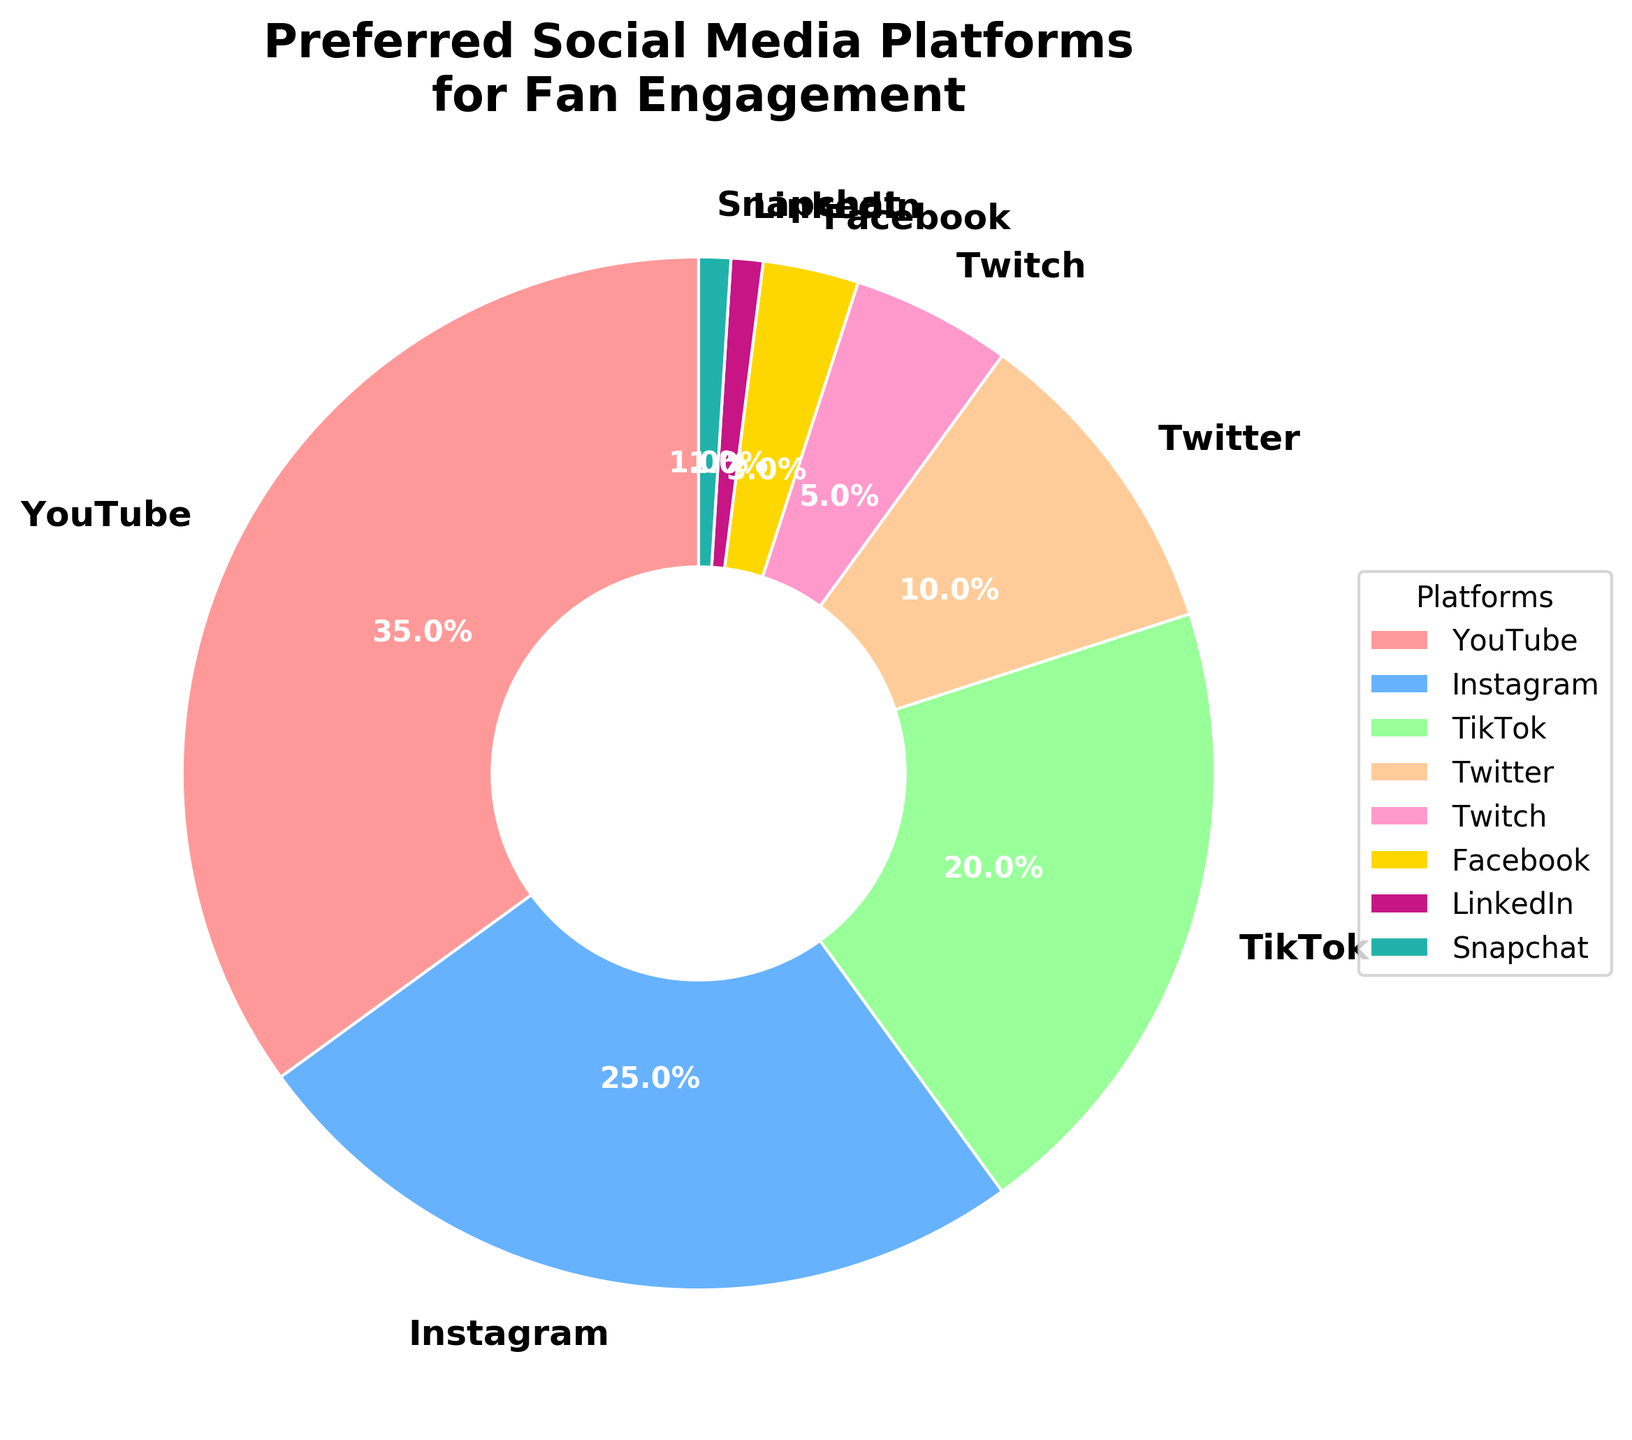what percentage of celebrities prefer YouTube for fan engagement? The figure shows a pie chart with different social media platforms and their corresponding percentages. To find the percentage of celebrities who prefer YouTube, simply refer to the slice labeled "YouTube".
Answer: 35% How does the preference for Instagram compare to Twitter? Look at the slices labeled "Instagram" and "Twitter" in the pie chart. Instagram has a larger slice. From the labels, Instagram is 25% and Twitter is 10%. Since 25% is greater than 10%, celebrities prefer Instagram more than Twitter.
Answer: Instagram (25%) is preferred more than Twitter (10%) If we combine the preferences for TikTok and Twitch, what percentage do we get? Find the percentages for TikTok and Twitch from the pie chart. TikTok is 20% and Twitch is 5%. Add these two percentages together: 20% + 5% = 25%.
Answer: 25% Which platform is the least preferred among the celebrities for fan engagement? Check the smallest slice in the pie chart. The platforms with the smallest slices are LinkedIn and Snapchat, both at 1%. Since they have the same percentage, they are equally the least preferred.
Answer: LinkedIn (1%) and Snapchat (1%) What is the total percentage of celebrities who prefer YouTube, Instagram, and TikTok combined? Find the percentages for YouTube, Instagram, and TikTok in the pie chart. YouTube is 35%, Instagram is 25%, and TikTok is 20%. Add these three percentages together: 35% + 25% + 20% = 80%.
Answer: 80% Which platform has roughly a third of the overall preferences? Look at the slices and their percentages from the pie chart. Identify the one that is close to but less than a third (approximately 33.33%). YouTube is 35%, which is closest to one-third of the total pie.
Answer: YouTube (35%) What percentage of social media preference do platforms other than YouTube, Instagram, and TikTok make up? Calculate the sum of percentages for YouTube, Instagram, and TikTok: 35% + 25% + 20% = 80%. Subtract this from 100% to get the percentage for the remaining platforms: 100% - 80% = 20%.
Answer: 20% Are there more celebrities preferring Twitter than Facebook and Twitch combined? Find the percentages for Twitter, Facebook, and Twitch from the pie chart. Twitter is 10%, Facebook is 3%, and Twitch is 5%. Add Facebook and Twitch: 3% + 5% = 8%. Compare this to Twitter's 10%. Since 10% is greater than 8%, more celebrities prefer Twitter.
Answer: Yes, 10% vs 8% What is the combined preference percentage for Snapchat and LinkedIn? Find the percentages for Snapchat and LinkedIn from the pie chart. Both are 1%. Add these two percentages together: 1% + 1% = 2%.
Answer: 2% If a new platform captured 10% of the preferences, what would be the new total for celebs who prefer platforms other than YouTube, Instagram, and TikTok? First, calculate the current total for YouTube, Instagram, and TikTok: 35% + 25% + 20% = 80%. Then subtract this from 100% to get the current percentage for other platforms: 100% - 80% = 20%. If a new platform gets 10%, then subtract this 10% from 20%: 20% - 10% = 10%.
Answer: 10% 